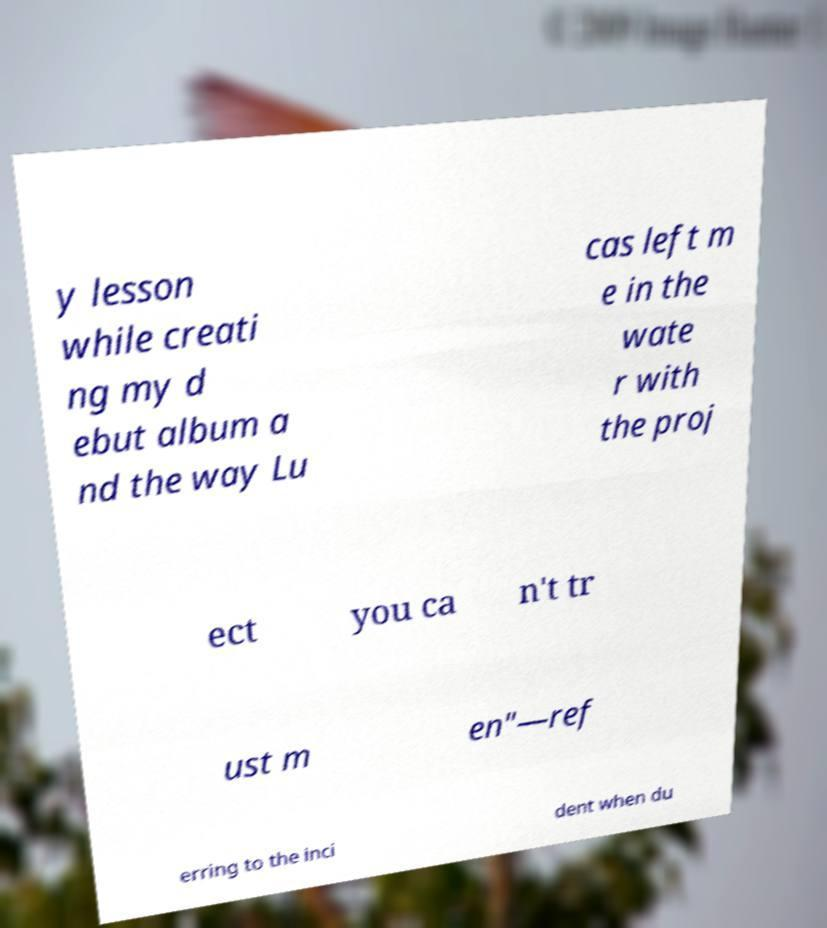Can you read and provide the text displayed in the image?This photo seems to have some interesting text. Can you extract and type it out for me? y lesson while creati ng my d ebut album a nd the way Lu cas left m e in the wate r with the proj ect you ca n't tr ust m en"—ref erring to the inci dent when du 